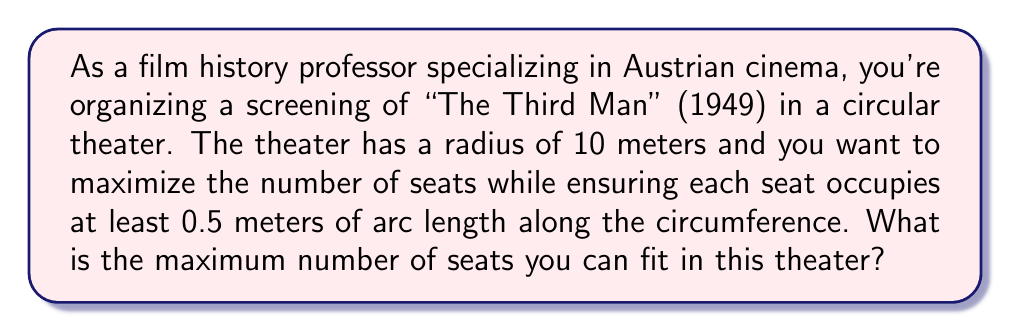What is the answer to this math problem? To solve this problem, we need to follow these steps:

1) First, we need to calculate the circumference of the theater. The formula for circumference is:

   $$C = 2\pi r$$

   Where $r$ is the radius of the circle.

2) Given that the radius is 10 meters, we can calculate the circumference:

   $$C = 2\pi (10) = 20\pi \approx 62.83 \text{ meters}$$

3) Now, we know that each seat needs to occupy at least 0.5 meters of arc length along the circumference. To find the maximum number of seats, we need to divide the total circumference by the minimum seat width:

   $$\text{Maximum number of seats} = \frac{\text{Circumference}}{\text{Minimum seat width}}$$

4) Substituting our values:

   $$\text{Maximum number of seats} = \frac{20\pi}{0.5} = 40\pi$$

5) Since we can't have a fractional number of seats, we need to round down to the nearest whole number:

   $$\text{Maximum number of seats} = \lfloor 40\pi \rfloor = \lfloor 125.66... \rfloor = 125$$

Therefore, the maximum number of seats that can be fitted in the theater is 125.

[asy]
import geometry;

size(200);
real r = 5; // scaled down for visibility
path theater = circle((0,0), r);
draw(theater);

for (int i = 0; i < 125; ++i) {
    real angle = 2*pi*i/125;
    dot((r*cos(angle), r*sin(angle)), red);
}

label("10m", (r/2,0), E);
draw((0,0)--(r,0), arrow=Arrow);
[/asy]
Answer: 125 seats 